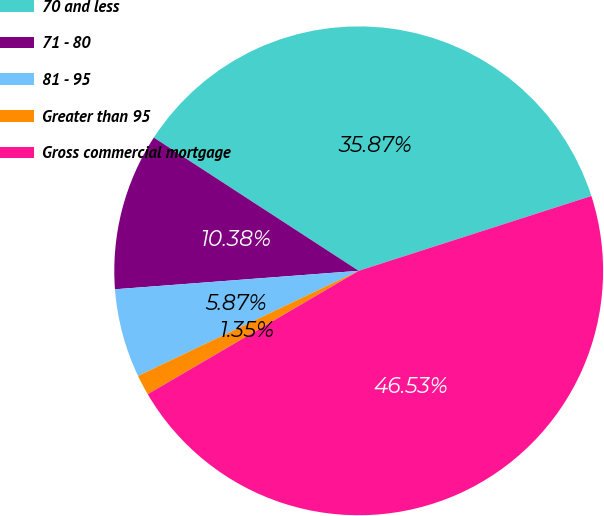Convert chart. <chart><loc_0><loc_0><loc_500><loc_500><pie_chart><fcel>70 and less<fcel>71 - 80<fcel>81 - 95<fcel>Greater than 95<fcel>Gross commercial mortgage<nl><fcel>35.87%<fcel>10.38%<fcel>5.87%<fcel>1.35%<fcel>46.53%<nl></chart> 